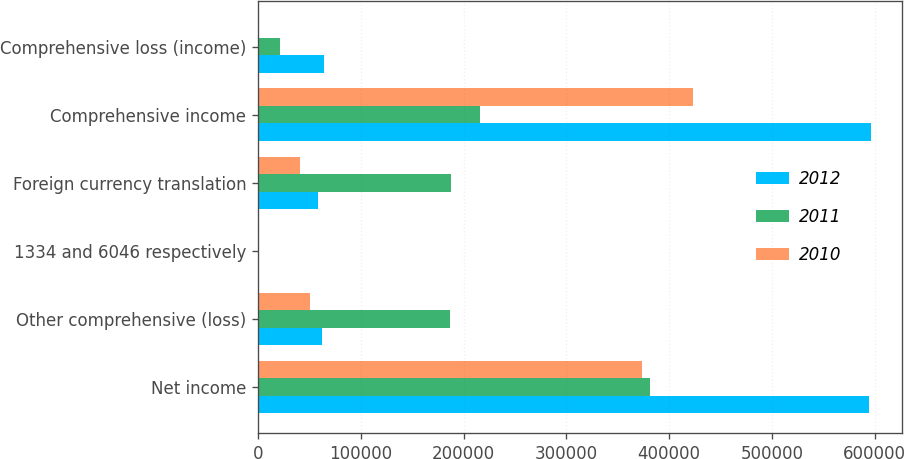Convert chart. <chart><loc_0><loc_0><loc_500><loc_500><stacked_bar_chart><ecel><fcel>Net income<fcel>Other comprehensive (loss)<fcel>1334 and 6046 respectively<fcel>Foreign currency translation<fcel>Comprehensive income<fcel>Comprehensive loss (income)<nl><fcel>2012<fcel>594025<fcel>62075<fcel>1132<fcel>58387<fcel>596553<fcel>64603<nl><fcel>2011<fcel>381840<fcel>187120<fcel>225<fcel>187466<fcel>215792<fcel>21072<nl><fcel>2010<fcel>373606<fcel>50702<fcel>118<fcel>41081<fcel>423638<fcel>670<nl></chart> 